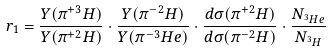Convert formula to latex. <formula><loc_0><loc_0><loc_500><loc_500>r _ { 1 } = \frac { Y ( \pi ^ { + 3 } H ) } { Y ( \pi ^ { + 2 } H ) } \cdot \frac { Y ( \pi ^ { - 2 } H ) } { Y ( \pi ^ { - 3 } H e ) } \cdot \frac { d \sigma ( \pi ^ { + 2 } H ) } { d \sigma ( \pi ^ { - 2 } H ) } \cdot \frac { N _ { ^ { 3 } H e } } { N _ { ^ { 3 } H } }</formula> 